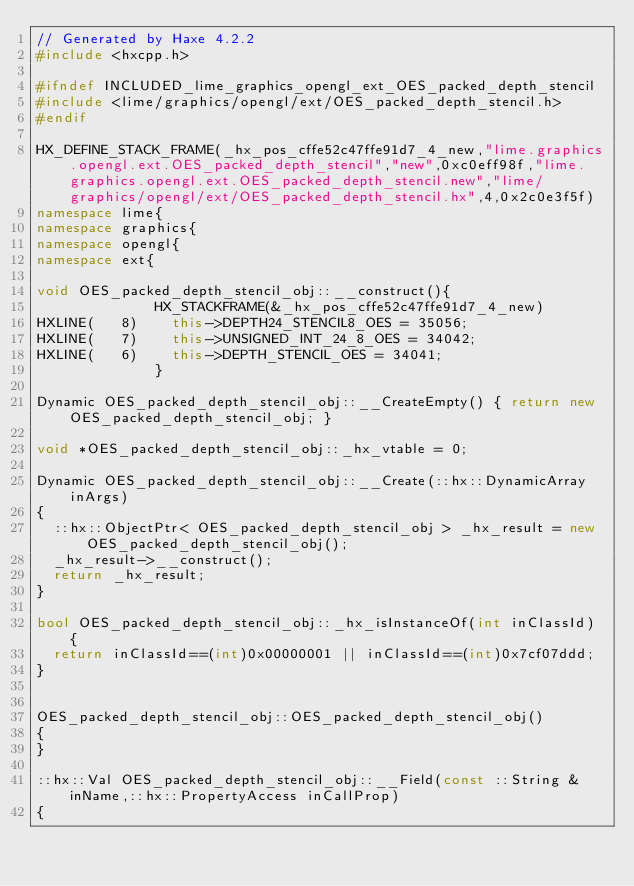Convert code to text. <code><loc_0><loc_0><loc_500><loc_500><_C++_>// Generated by Haxe 4.2.2
#include <hxcpp.h>

#ifndef INCLUDED_lime_graphics_opengl_ext_OES_packed_depth_stencil
#include <lime/graphics/opengl/ext/OES_packed_depth_stencil.h>
#endif

HX_DEFINE_STACK_FRAME(_hx_pos_cffe52c47ffe91d7_4_new,"lime.graphics.opengl.ext.OES_packed_depth_stencil","new",0xc0eff98f,"lime.graphics.opengl.ext.OES_packed_depth_stencil.new","lime/graphics/opengl/ext/OES_packed_depth_stencil.hx",4,0x2c0e3f5f)
namespace lime{
namespace graphics{
namespace opengl{
namespace ext{

void OES_packed_depth_stencil_obj::__construct(){
            	HX_STACKFRAME(&_hx_pos_cffe52c47ffe91d7_4_new)
HXLINE(   8)		this->DEPTH24_STENCIL8_OES = 35056;
HXLINE(   7)		this->UNSIGNED_INT_24_8_OES = 34042;
HXLINE(   6)		this->DEPTH_STENCIL_OES = 34041;
            	}

Dynamic OES_packed_depth_stencil_obj::__CreateEmpty() { return new OES_packed_depth_stencil_obj; }

void *OES_packed_depth_stencil_obj::_hx_vtable = 0;

Dynamic OES_packed_depth_stencil_obj::__Create(::hx::DynamicArray inArgs)
{
	::hx::ObjectPtr< OES_packed_depth_stencil_obj > _hx_result = new OES_packed_depth_stencil_obj();
	_hx_result->__construct();
	return _hx_result;
}

bool OES_packed_depth_stencil_obj::_hx_isInstanceOf(int inClassId) {
	return inClassId==(int)0x00000001 || inClassId==(int)0x7cf07ddd;
}


OES_packed_depth_stencil_obj::OES_packed_depth_stencil_obj()
{
}

::hx::Val OES_packed_depth_stencil_obj::__Field(const ::String &inName,::hx::PropertyAccess inCallProp)
{</code> 